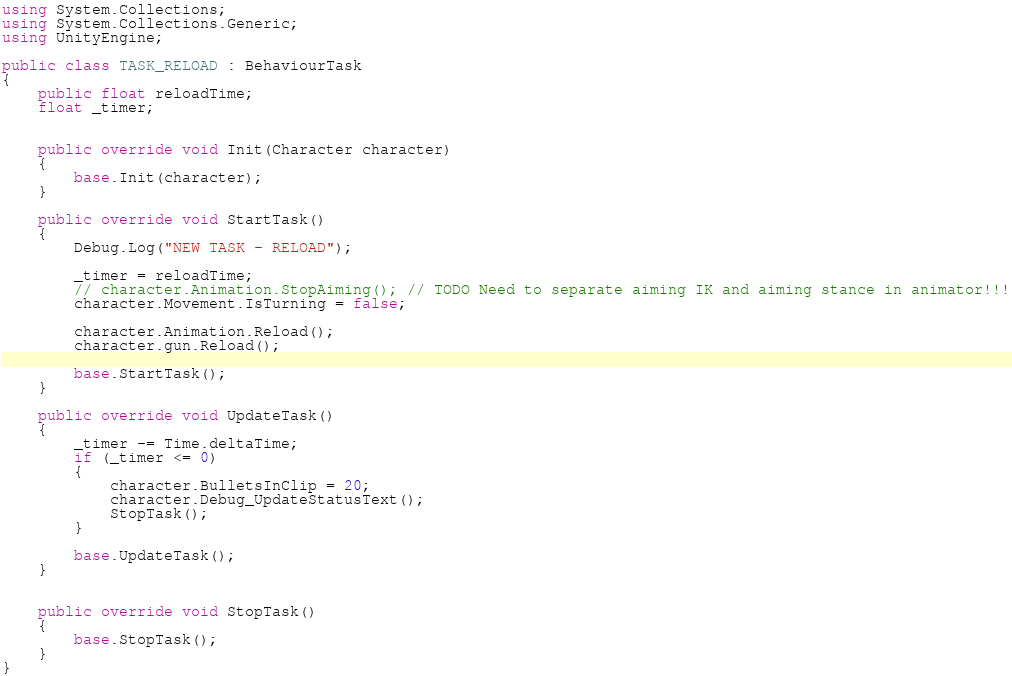Convert code to text. <code><loc_0><loc_0><loc_500><loc_500><_C#_>using System.Collections;
using System.Collections.Generic;
using UnityEngine;

public class TASK_RELOAD : BehaviourTask
{
    public float reloadTime;
    float _timer;


    public override void Init(Character character)
    {
        base.Init(character);
    }

    public override void StartTask()
    {
        Debug.Log("NEW TASK - RELOAD");

        _timer = reloadTime;
        // character.Animation.StopAiming(); // TODO Need to separate aiming IK and aiming stance in animator!!!
        character.Movement.IsTurning = false;

        character.Animation.Reload();
        character.gun.Reload();

        base.StartTask();
    }

    public override void UpdateTask()
    {
        _timer -= Time.deltaTime;
        if (_timer <= 0)
        {
            character.BulletsInClip = 20;
            character.Debug_UpdateStatusText();
            StopTask();
        }

        base.UpdateTask();
    }


    public override void StopTask()
    {
        base.StopTask();
    }
}
</code> 